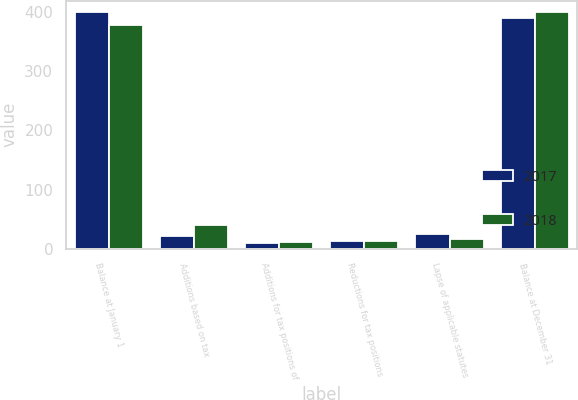<chart> <loc_0><loc_0><loc_500><loc_500><stacked_bar_chart><ecel><fcel>Balance at January 1<fcel>Additions based on tax<fcel>Additions for tax positions of<fcel>Reductions for tax positions<fcel>Lapse of applicable statutes<fcel>Balance at December 31<nl><fcel>2017<fcel>399<fcel>22<fcel>10<fcel>14<fcel>25<fcel>390<nl><fcel>2018<fcel>377<fcel>40<fcel>11<fcel>13<fcel>16<fcel>399<nl></chart> 